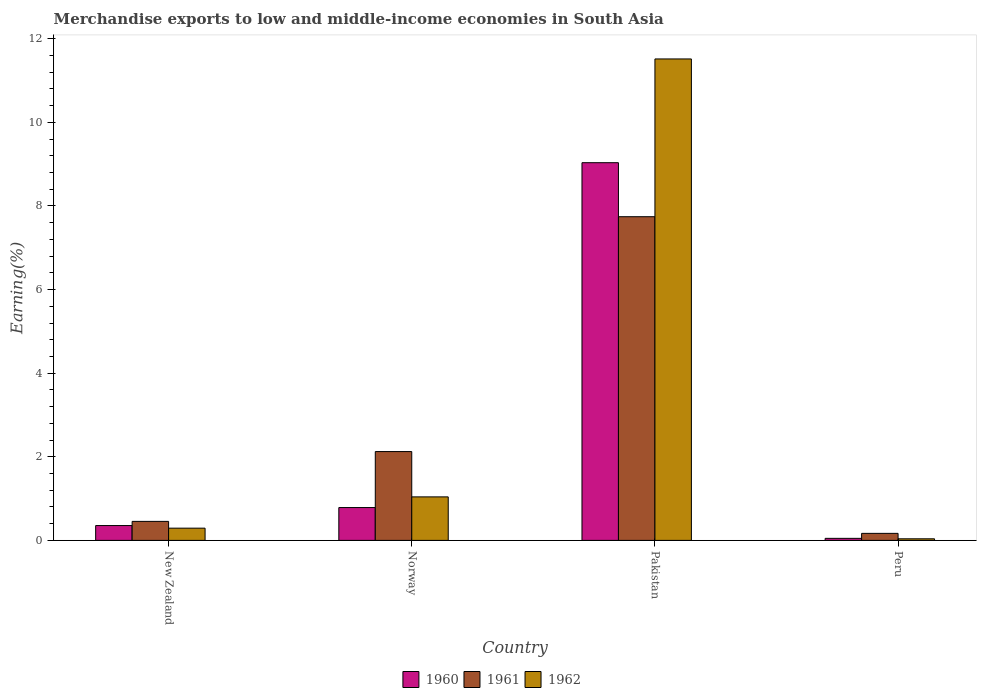How many groups of bars are there?
Keep it short and to the point. 4. Are the number of bars per tick equal to the number of legend labels?
Provide a succinct answer. Yes. Are the number of bars on each tick of the X-axis equal?
Provide a short and direct response. Yes. How many bars are there on the 1st tick from the left?
Give a very brief answer. 3. What is the label of the 1st group of bars from the left?
Offer a very short reply. New Zealand. What is the percentage of amount earned from merchandise exports in 1962 in Pakistan?
Give a very brief answer. 11.52. Across all countries, what is the maximum percentage of amount earned from merchandise exports in 1960?
Provide a short and direct response. 9.04. Across all countries, what is the minimum percentage of amount earned from merchandise exports in 1961?
Provide a succinct answer. 0.17. In which country was the percentage of amount earned from merchandise exports in 1961 maximum?
Your answer should be compact. Pakistan. What is the total percentage of amount earned from merchandise exports in 1962 in the graph?
Your answer should be very brief. 12.89. What is the difference between the percentage of amount earned from merchandise exports in 1960 in Norway and that in Pakistan?
Your answer should be very brief. -8.25. What is the difference between the percentage of amount earned from merchandise exports in 1961 in Peru and the percentage of amount earned from merchandise exports in 1960 in Pakistan?
Give a very brief answer. -8.87. What is the average percentage of amount earned from merchandise exports in 1960 per country?
Offer a very short reply. 2.56. What is the difference between the percentage of amount earned from merchandise exports of/in 1961 and percentage of amount earned from merchandise exports of/in 1960 in Norway?
Offer a very short reply. 1.34. In how many countries, is the percentage of amount earned from merchandise exports in 1960 greater than 4.4 %?
Make the answer very short. 1. What is the ratio of the percentage of amount earned from merchandise exports in 1962 in Norway to that in Pakistan?
Give a very brief answer. 0.09. What is the difference between the highest and the second highest percentage of amount earned from merchandise exports in 1961?
Keep it short and to the point. -1.67. What is the difference between the highest and the lowest percentage of amount earned from merchandise exports in 1961?
Your response must be concise. 7.58. Is the sum of the percentage of amount earned from merchandise exports in 1960 in New Zealand and Pakistan greater than the maximum percentage of amount earned from merchandise exports in 1962 across all countries?
Offer a very short reply. No. What does the 1st bar from the left in Peru represents?
Your answer should be compact. 1960. What does the 3rd bar from the right in Pakistan represents?
Keep it short and to the point. 1960. Is it the case that in every country, the sum of the percentage of amount earned from merchandise exports in 1961 and percentage of amount earned from merchandise exports in 1962 is greater than the percentage of amount earned from merchandise exports in 1960?
Your response must be concise. Yes. How many bars are there?
Provide a short and direct response. 12. Are all the bars in the graph horizontal?
Your answer should be compact. No. How many countries are there in the graph?
Your answer should be compact. 4. Does the graph contain grids?
Offer a very short reply. No. Where does the legend appear in the graph?
Ensure brevity in your answer.  Bottom center. How many legend labels are there?
Offer a terse response. 3. What is the title of the graph?
Offer a very short reply. Merchandise exports to low and middle-income economies in South Asia. What is the label or title of the Y-axis?
Offer a terse response. Earning(%). What is the Earning(%) of 1960 in New Zealand?
Ensure brevity in your answer.  0.36. What is the Earning(%) of 1961 in New Zealand?
Your answer should be very brief. 0.45. What is the Earning(%) in 1962 in New Zealand?
Provide a succinct answer. 0.29. What is the Earning(%) of 1960 in Norway?
Provide a short and direct response. 0.79. What is the Earning(%) of 1961 in Norway?
Make the answer very short. 2.12. What is the Earning(%) in 1962 in Norway?
Your answer should be very brief. 1.04. What is the Earning(%) of 1960 in Pakistan?
Your answer should be compact. 9.04. What is the Earning(%) of 1961 in Pakistan?
Provide a short and direct response. 7.74. What is the Earning(%) of 1962 in Pakistan?
Your response must be concise. 11.52. What is the Earning(%) of 1960 in Peru?
Your answer should be compact. 0.05. What is the Earning(%) of 1961 in Peru?
Give a very brief answer. 0.17. What is the Earning(%) of 1962 in Peru?
Provide a succinct answer. 0.04. Across all countries, what is the maximum Earning(%) of 1960?
Ensure brevity in your answer.  9.04. Across all countries, what is the maximum Earning(%) of 1961?
Offer a very short reply. 7.74. Across all countries, what is the maximum Earning(%) of 1962?
Offer a terse response. 11.52. Across all countries, what is the minimum Earning(%) of 1960?
Make the answer very short. 0.05. Across all countries, what is the minimum Earning(%) in 1961?
Keep it short and to the point. 0.17. Across all countries, what is the minimum Earning(%) in 1962?
Offer a terse response. 0.04. What is the total Earning(%) of 1960 in the graph?
Give a very brief answer. 10.22. What is the total Earning(%) of 1961 in the graph?
Your answer should be very brief. 10.49. What is the total Earning(%) in 1962 in the graph?
Your response must be concise. 12.89. What is the difference between the Earning(%) in 1960 in New Zealand and that in Norway?
Ensure brevity in your answer.  -0.43. What is the difference between the Earning(%) in 1961 in New Zealand and that in Norway?
Give a very brief answer. -1.67. What is the difference between the Earning(%) of 1962 in New Zealand and that in Norway?
Provide a succinct answer. -0.75. What is the difference between the Earning(%) of 1960 in New Zealand and that in Pakistan?
Offer a very short reply. -8.68. What is the difference between the Earning(%) in 1961 in New Zealand and that in Pakistan?
Give a very brief answer. -7.29. What is the difference between the Earning(%) of 1962 in New Zealand and that in Pakistan?
Offer a terse response. -11.22. What is the difference between the Earning(%) in 1960 in New Zealand and that in Peru?
Your answer should be compact. 0.31. What is the difference between the Earning(%) of 1961 in New Zealand and that in Peru?
Your answer should be compact. 0.29. What is the difference between the Earning(%) in 1962 in New Zealand and that in Peru?
Offer a terse response. 0.25. What is the difference between the Earning(%) in 1960 in Norway and that in Pakistan?
Your answer should be compact. -8.25. What is the difference between the Earning(%) of 1961 in Norway and that in Pakistan?
Make the answer very short. -5.62. What is the difference between the Earning(%) in 1962 in Norway and that in Pakistan?
Offer a very short reply. -10.48. What is the difference between the Earning(%) in 1960 in Norway and that in Peru?
Ensure brevity in your answer.  0.74. What is the difference between the Earning(%) of 1961 in Norway and that in Peru?
Offer a very short reply. 1.96. What is the difference between the Earning(%) in 1962 in Norway and that in Peru?
Keep it short and to the point. 1. What is the difference between the Earning(%) of 1960 in Pakistan and that in Peru?
Keep it short and to the point. 8.99. What is the difference between the Earning(%) in 1961 in Pakistan and that in Peru?
Give a very brief answer. 7.58. What is the difference between the Earning(%) in 1962 in Pakistan and that in Peru?
Offer a terse response. 11.48. What is the difference between the Earning(%) of 1960 in New Zealand and the Earning(%) of 1961 in Norway?
Offer a terse response. -1.77. What is the difference between the Earning(%) in 1960 in New Zealand and the Earning(%) in 1962 in Norway?
Your answer should be compact. -0.69. What is the difference between the Earning(%) of 1961 in New Zealand and the Earning(%) of 1962 in Norway?
Offer a very short reply. -0.59. What is the difference between the Earning(%) in 1960 in New Zealand and the Earning(%) in 1961 in Pakistan?
Your answer should be compact. -7.39. What is the difference between the Earning(%) in 1960 in New Zealand and the Earning(%) in 1962 in Pakistan?
Offer a terse response. -11.16. What is the difference between the Earning(%) of 1961 in New Zealand and the Earning(%) of 1962 in Pakistan?
Your answer should be very brief. -11.06. What is the difference between the Earning(%) of 1960 in New Zealand and the Earning(%) of 1961 in Peru?
Your response must be concise. 0.19. What is the difference between the Earning(%) of 1960 in New Zealand and the Earning(%) of 1962 in Peru?
Ensure brevity in your answer.  0.32. What is the difference between the Earning(%) of 1961 in New Zealand and the Earning(%) of 1962 in Peru?
Offer a very short reply. 0.42. What is the difference between the Earning(%) of 1960 in Norway and the Earning(%) of 1961 in Pakistan?
Provide a succinct answer. -6.96. What is the difference between the Earning(%) of 1960 in Norway and the Earning(%) of 1962 in Pakistan?
Make the answer very short. -10.73. What is the difference between the Earning(%) of 1961 in Norway and the Earning(%) of 1962 in Pakistan?
Your answer should be compact. -9.39. What is the difference between the Earning(%) in 1960 in Norway and the Earning(%) in 1961 in Peru?
Make the answer very short. 0.62. What is the difference between the Earning(%) of 1960 in Norway and the Earning(%) of 1962 in Peru?
Make the answer very short. 0.75. What is the difference between the Earning(%) of 1961 in Norway and the Earning(%) of 1962 in Peru?
Offer a very short reply. 2.09. What is the difference between the Earning(%) in 1960 in Pakistan and the Earning(%) in 1961 in Peru?
Provide a succinct answer. 8.87. What is the difference between the Earning(%) in 1960 in Pakistan and the Earning(%) in 1962 in Peru?
Make the answer very short. 9. What is the difference between the Earning(%) of 1961 in Pakistan and the Earning(%) of 1962 in Peru?
Offer a very short reply. 7.71. What is the average Earning(%) of 1960 per country?
Make the answer very short. 2.56. What is the average Earning(%) in 1961 per country?
Your answer should be compact. 2.62. What is the average Earning(%) of 1962 per country?
Make the answer very short. 3.22. What is the difference between the Earning(%) of 1960 and Earning(%) of 1961 in New Zealand?
Make the answer very short. -0.1. What is the difference between the Earning(%) of 1960 and Earning(%) of 1962 in New Zealand?
Provide a succinct answer. 0.06. What is the difference between the Earning(%) in 1961 and Earning(%) in 1962 in New Zealand?
Offer a terse response. 0.16. What is the difference between the Earning(%) of 1960 and Earning(%) of 1961 in Norway?
Your answer should be very brief. -1.34. What is the difference between the Earning(%) of 1960 and Earning(%) of 1962 in Norway?
Ensure brevity in your answer.  -0.26. What is the difference between the Earning(%) in 1961 and Earning(%) in 1962 in Norway?
Provide a succinct answer. 1.08. What is the difference between the Earning(%) in 1960 and Earning(%) in 1961 in Pakistan?
Your answer should be very brief. 1.29. What is the difference between the Earning(%) of 1960 and Earning(%) of 1962 in Pakistan?
Give a very brief answer. -2.48. What is the difference between the Earning(%) in 1961 and Earning(%) in 1962 in Pakistan?
Your answer should be compact. -3.77. What is the difference between the Earning(%) of 1960 and Earning(%) of 1961 in Peru?
Provide a short and direct response. -0.12. What is the difference between the Earning(%) in 1960 and Earning(%) in 1962 in Peru?
Ensure brevity in your answer.  0.01. What is the difference between the Earning(%) in 1961 and Earning(%) in 1962 in Peru?
Make the answer very short. 0.13. What is the ratio of the Earning(%) of 1960 in New Zealand to that in Norway?
Provide a short and direct response. 0.45. What is the ratio of the Earning(%) in 1961 in New Zealand to that in Norway?
Give a very brief answer. 0.21. What is the ratio of the Earning(%) of 1962 in New Zealand to that in Norway?
Provide a short and direct response. 0.28. What is the ratio of the Earning(%) in 1960 in New Zealand to that in Pakistan?
Keep it short and to the point. 0.04. What is the ratio of the Earning(%) of 1961 in New Zealand to that in Pakistan?
Provide a short and direct response. 0.06. What is the ratio of the Earning(%) in 1962 in New Zealand to that in Pakistan?
Keep it short and to the point. 0.03. What is the ratio of the Earning(%) in 1960 in New Zealand to that in Peru?
Make the answer very short. 7.26. What is the ratio of the Earning(%) in 1961 in New Zealand to that in Peru?
Your answer should be compact. 2.71. What is the ratio of the Earning(%) of 1962 in New Zealand to that in Peru?
Keep it short and to the point. 7.69. What is the ratio of the Earning(%) of 1960 in Norway to that in Pakistan?
Keep it short and to the point. 0.09. What is the ratio of the Earning(%) in 1961 in Norway to that in Pakistan?
Provide a succinct answer. 0.27. What is the ratio of the Earning(%) of 1962 in Norway to that in Pakistan?
Your answer should be very brief. 0.09. What is the ratio of the Earning(%) in 1960 in Norway to that in Peru?
Provide a short and direct response. 16.05. What is the ratio of the Earning(%) in 1961 in Norway to that in Peru?
Ensure brevity in your answer.  12.65. What is the ratio of the Earning(%) in 1962 in Norway to that in Peru?
Offer a terse response. 27.36. What is the ratio of the Earning(%) of 1960 in Pakistan to that in Peru?
Make the answer very short. 184.68. What is the ratio of the Earning(%) of 1961 in Pakistan to that in Peru?
Make the answer very short. 46.1. What is the ratio of the Earning(%) in 1962 in Pakistan to that in Peru?
Your answer should be compact. 302.79. What is the difference between the highest and the second highest Earning(%) in 1960?
Ensure brevity in your answer.  8.25. What is the difference between the highest and the second highest Earning(%) in 1961?
Offer a very short reply. 5.62. What is the difference between the highest and the second highest Earning(%) of 1962?
Offer a very short reply. 10.48. What is the difference between the highest and the lowest Earning(%) of 1960?
Provide a succinct answer. 8.99. What is the difference between the highest and the lowest Earning(%) in 1961?
Provide a succinct answer. 7.58. What is the difference between the highest and the lowest Earning(%) of 1962?
Keep it short and to the point. 11.48. 